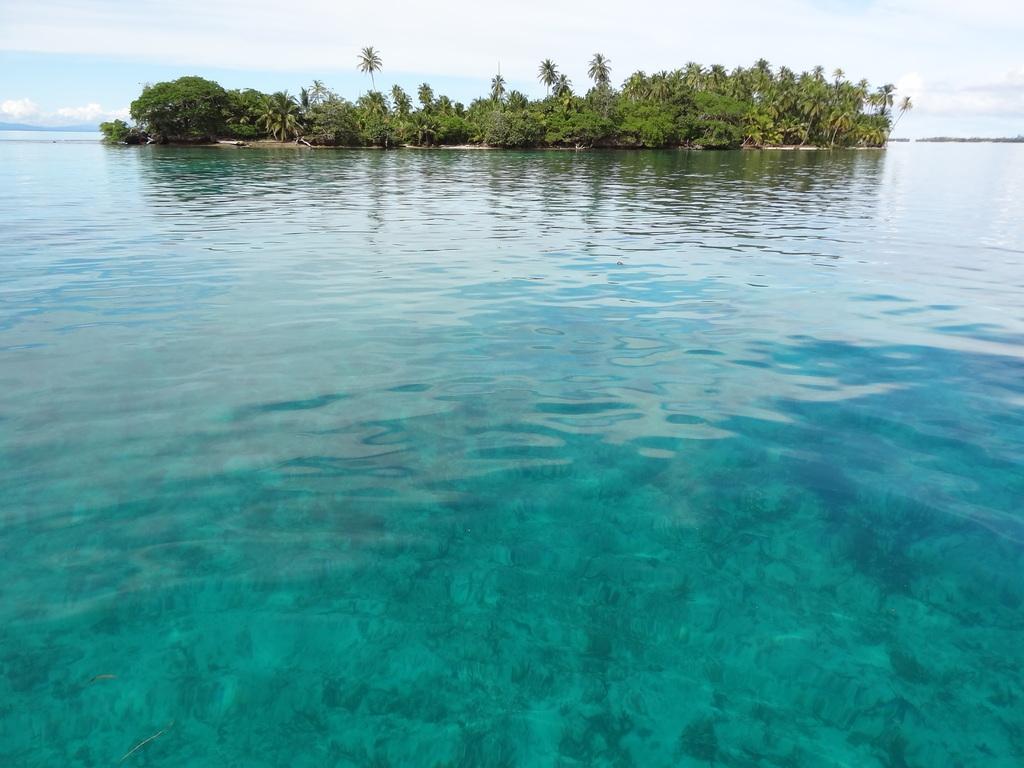Please provide a concise description of this image. In this image I can see the water which are blue in color and I can see few trees on the island. In the background I can see the sky. 